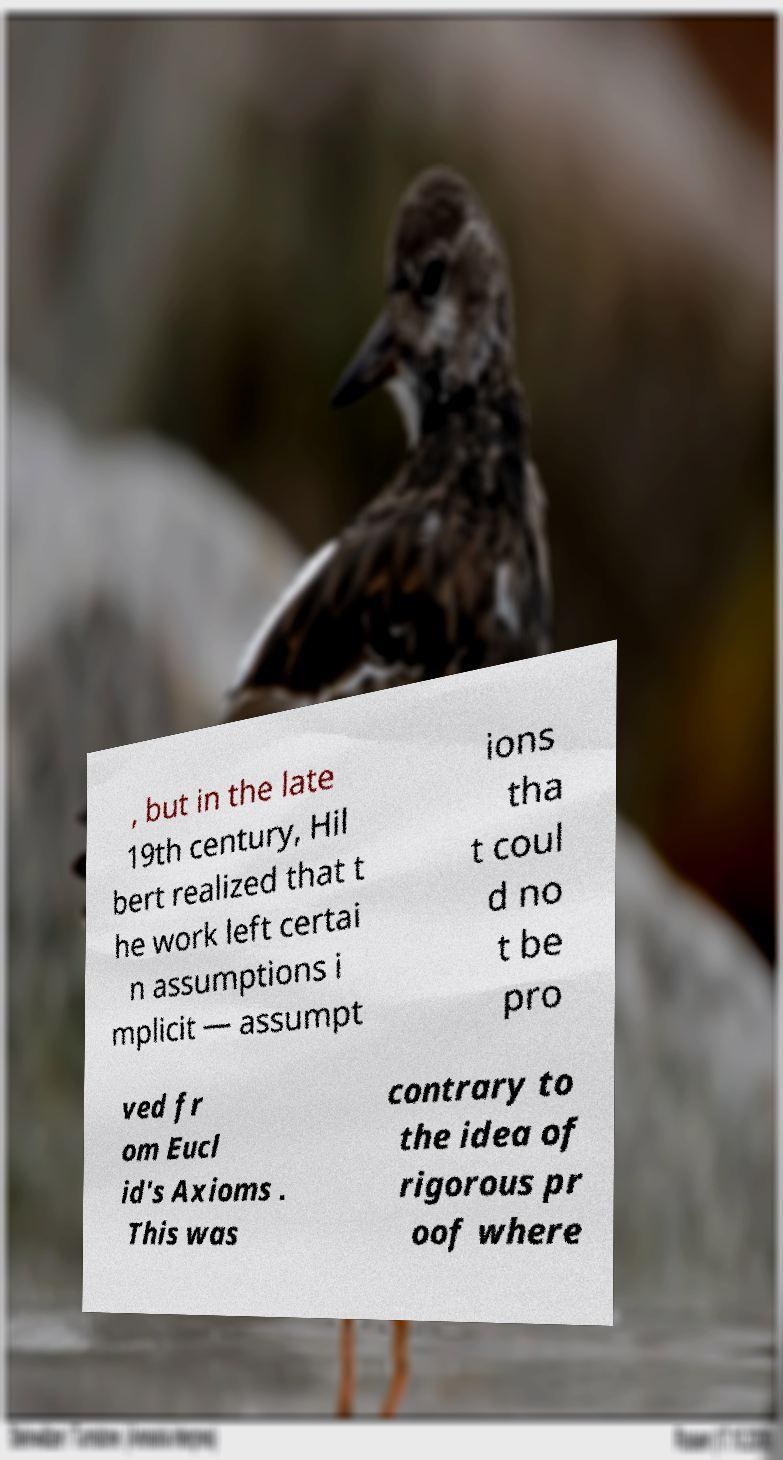Could you extract and type out the text from this image? , but in the late 19th century, Hil bert realized that t he work left certai n assumptions i mplicit — assumpt ions tha t coul d no t be pro ved fr om Eucl id's Axioms . This was contrary to the idea of rigorous pr oof where 